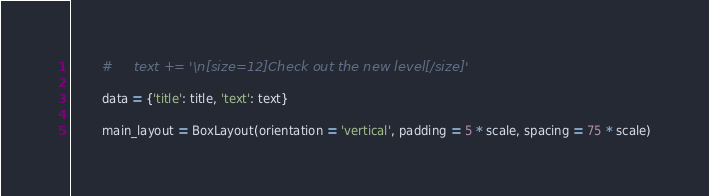<code> <loc_0><loc_0><loc_500><loc_500><_Python_>        #     text += '\n[size=12]Check out the new level[/size]'

        data = {'title': title, 'text': text}

        main_layout = BoxLayout(orientation = 'vertical', padding = 5 * scale, spacing = 75 * scale)</code> 